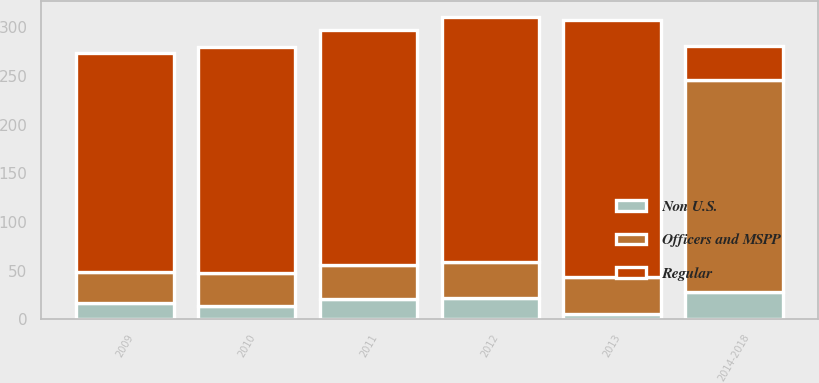Convert chart to OTSL. <chart><loc_0><loc_0><loc_500><loc_500><stacked_bar_chart><ecel><fcel>2009<fcel>2010<fcel>2011<fcel>2012<fcel>2013<fcel>2014-2018<nl><fcel>Regular<fcel>225<fcel>232<fcel>241<fcel>252<fcel>265<fcel>35<nl><fcel>Non U.S.<fcel>17<fcel>14<fcel>21<fcel>22<fcel>5<fcel>28<nl><fcel>Officers and MSPP<fcel>32<fcel>34<fcel>35<fcel>37<fcel>38<fcel>218<nl></chart> 